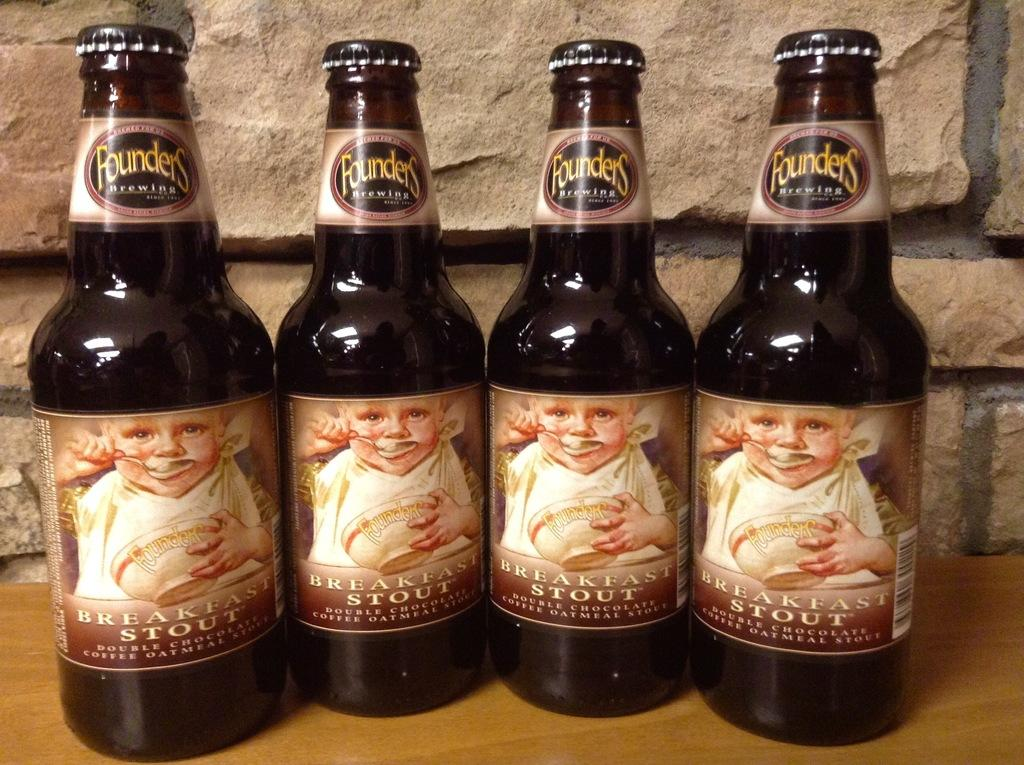Provide a one-sentence caption for the provided image. Four different bottles from the company Founders Brewing. 